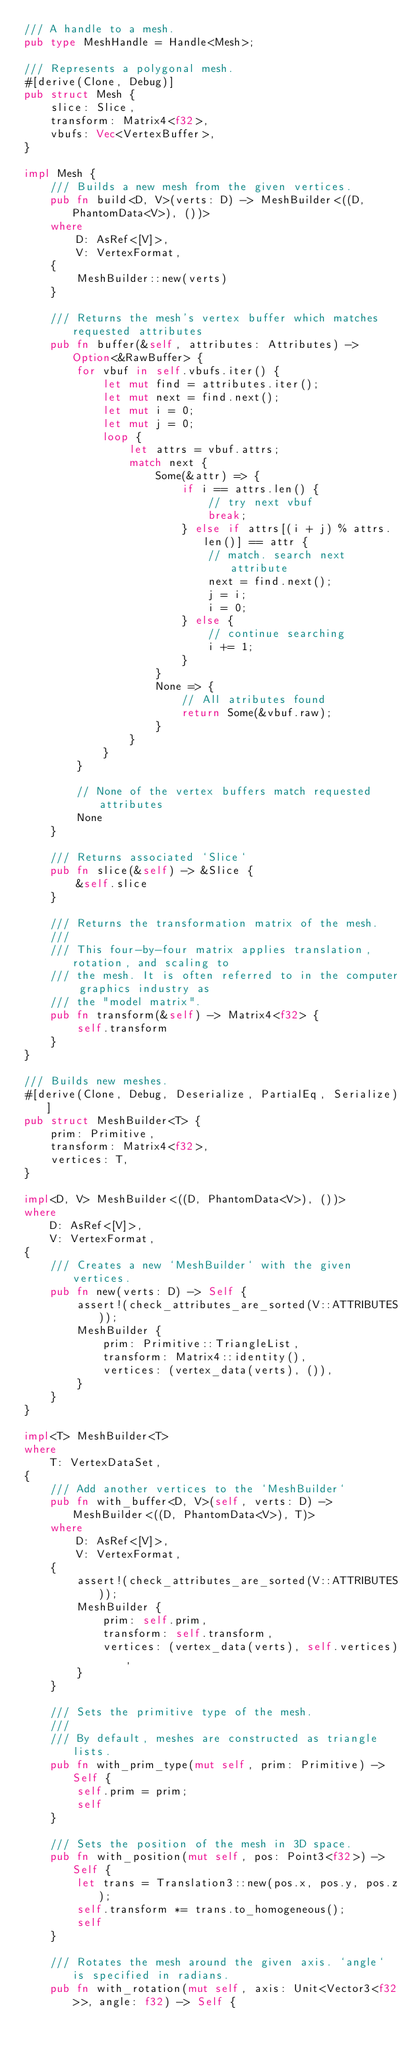<code> <loc_0><loc_0><loc_500><loc_500><_Rust_>/// A handle to a mesh.
pub type MeshHandle = Handle<Mesh>;

/// Represents a polygonal mesh.
#[derive(Clone, Debug)]
pub struct Mesh {
    slice: Slice,
    transform: Matrix4<f32>,
    vbufs: Vec<VertexBuffer>,
}

impl Mesh {
    /// Builds a new mesh from the given vertices.
    pub fn build<D, V>(verts: D) -> MeshBuilder<((D, PhantomData<V>), ())>
    where
        D: AsRef<[V]>,
        V: VertexFormat,
    {
        MeshBuilder::new(verts)
    }

    /// Returns the mesh's vertex buffer which matches requested attributes
    pub fn buffer(&self, attributes: Attributes) -> Option<&RawBuffer> {
        for vbuf in self.vbufs.iter() {
            let mut find = attributes.iter();
            let mut next = find.next();
            let mut i = 0;
            let mut j = 0;
            loop {
                let attrs = vbuf.attrs;
                match next {
                    Some(&attr) => {
                        if i == attrs.len() {
                            // try next vbuf
                            break;
                        } else if attrs[(i + j) % attrs.len()] == attr {
                            // match. search next attribute
                            next = find.next();
                            j = i;
                            i = 0;
                        } else {
                            // continue searching
                            i += 1;
                        }
                    }
                    None => {
                        // All atributes found
                        return Some(&vbuf.raw);
                    }
                }
            }
        }

        // None of the vertex buffers match requested attributes
        None
    }

    /// Returns associated `Slice`
    pub fn slice(&self) -> &Slice {
        &self.slice
    }

    /// Returns the transformation matrix of the mesh.
    ///
    /// This four-by-four matrix applies translation, rotation, and scaling to
    /// the mesh. It is often referred to in the computer graphics industry as
    /// the "model matrix".
    pub fn transform(&self) -> Matrix4<f32> {
        self.transform
    }
}

/// Builds new meshes.
#[derive(Clone, Debug, Deserialize, PartialEq, Serialize)]
pub struct MeshBuilder<T> {
    prim: Primitive,
    transform: Matrix4<f32>,
    vertices: T,
}

impl<D, V> MeshBuilder<((D, PhantomData<V>), ())>
where
    D: AsRef<[V]>,
    V: VertexFormat,
{
    /// Creates a new `MeshBuilder` with the given vertices.
    pub fn new(verts: D) -> Self {
        assert!(check_attributes_are_sorted(V::ATTRIBUTES));
        MeshBuilder {
            prim: Primitive::TriangleList,
            transform: Matrix4::identity(),
            vertices: (vertex_data(verts), ()),
        }
    }
}

impl<T> MeshBuilder<T>
where
    T: VertexDataSet,
{
    /// Add another vertices to the `MeshBuilder`
    pub fn with_buffer<D, V>(self, verts: D) -> MeshBuilder<((D, PhantomData<V>), T)>
    where
        D: AsRef<[V]>,
        V: VertexFormat,
    {
        assert!(check_attributes_are_sorted(V::ATTRIBUTES));
        MeshBuilder {
            prim: self.prim,
            transform: self.transform,
            vertices: (vertex_data(verts), self.vertices),
        }
    }

    /// Sets the primitive type of the mesh.
    ///
    /// By default, meshes are constructed as triangle lists.
    pub fn with_prim_type(mut self, prim: Primitive) -> Self {
        self.prim = prim;
        self
    }

    /// Sets the position of the mesh in 3D space.
    pub fn with_position(mut self, pos: Point3<f32>) -> Self {
        let trans = Translation3::new(pos.x, pos.y, pos.z);
        self.transform *= trans.to_homogeneous();
        self
    }

    /// Rotates the mesh around the given axis. `angle` is specified in radians.
    pub fn with_rotation(mut self, axis: Unit<Vector3<f32>>, angle: f32) -> Self {</code> 